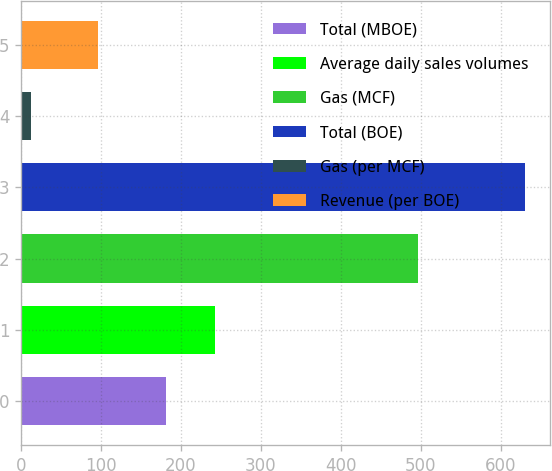Convert chart to OTSL. <chart><loc_0><loc_0><loc_500><loc_500><bar_chart><fcel>Total (MBOE)<fcel>Average daily sales volumes<fcel>Gas (MCF)<fcel>Total (BOE)<fcel>Gas (per MCF)<fcel>Revenue (per BOE)<nl><fcel>181<fcel>242.7<fcel>496<fcel>630<fcel>13.04<fcel>96.29<nl></chart> 